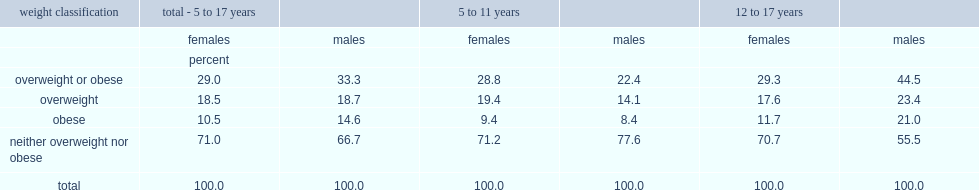What is the percentage of girls aged 5 to 17 were overweight or obese? 29.0. What is the percentage of boys aged 5 to 17 were overweight or obese? 33.3. Which gender in 12 to 17 were less likely to be overweight or obese? Females. What is the percentage of girls aged 12 to 17 were overweight or obese? 29.3. What is the percentage of boys aged 12 to 17 were overweight or obese? 44.5. What is the percentage of boys aged 12 to 17 were overweight or obese? 44.5. What is the percentage of boys aged 5 to 11 were overweight or obese? 22.4. What is the percentage of boys aged 12 to 17 were overweight? 23.4. What is the percentage of boys aged 5 to 11 were overweight? 14.1. What is the percentage of boys aged 12 to 17 were obese? 21.0. What is the percentage of boys aged 5 to 11 were obese? 8.4. Which age group of boys was more likely to be either overweight or obese? 12 to 17 years. 